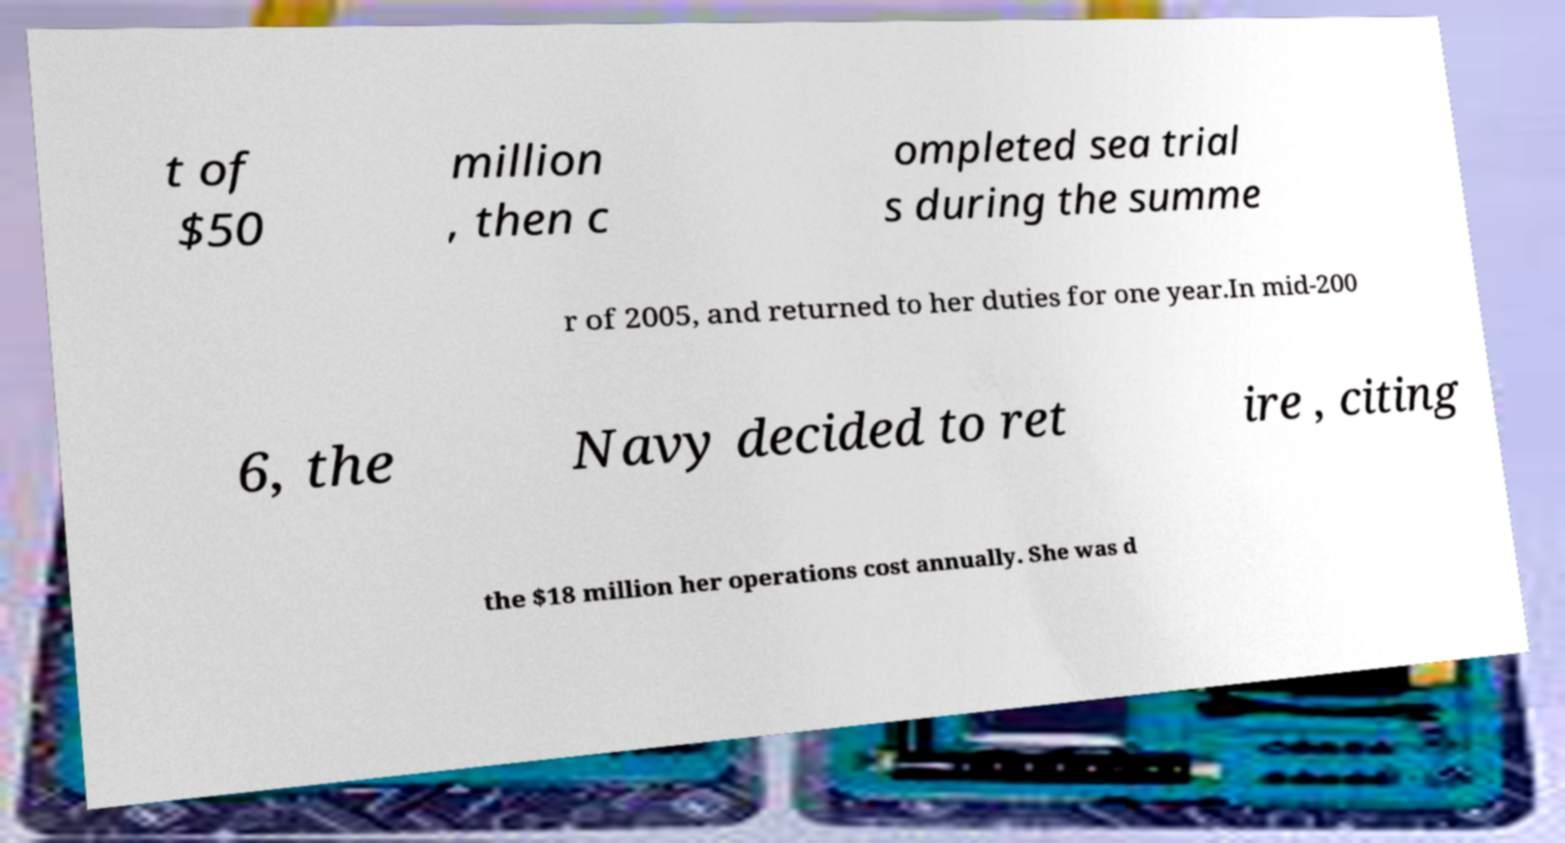I need the written content from this picture converted into text. Can you do that? t of $50 million , then c ompleted sea trial s during the summe r of 2005, and returned to her duties for one year.In mid-200 6, the Navy decided to ret ire , citing the $18 million her operations cost annually. She was d 